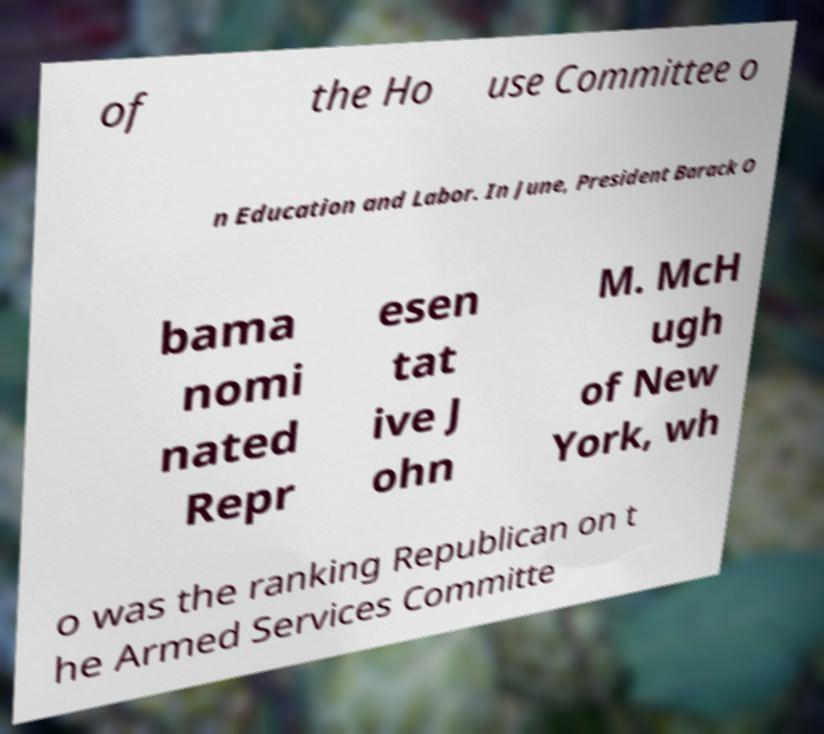Could you assist in decoding the text presented in this image and type it out clearly? of the Ho use Committee o n Education and Labor. In June, President Barack O bama nomi nated Repr esen tat ive J ohn M. McH ugh of New York, wh o was the ranking Republican on t he Armed Services Committe 